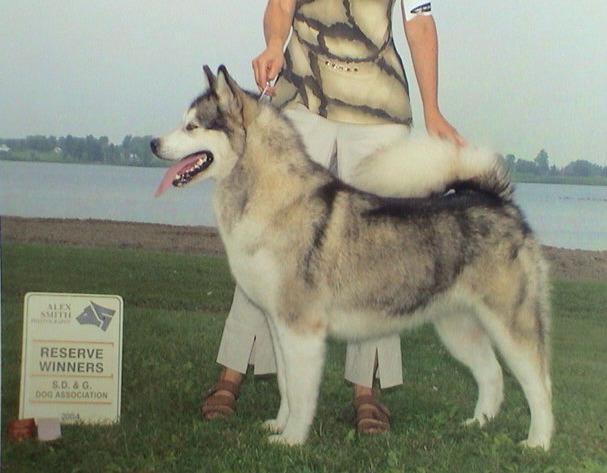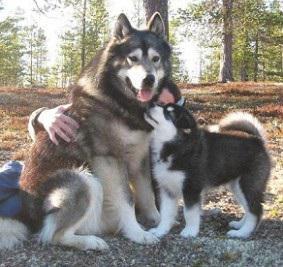The first image is the image on the left, the second image is the image on the right. Examine the images to the left and right. Is the description "The right image features one person standing behind a dog standing in profile, and the left image includes a person crouching behind a dog." accurate? Answer yes or no. No. The first image is the image on the left, the second image is the image on the right. Assess this claim about the two images: "The left and right image contains the same number of huskies.". Correct or not? Answer yes or no. No. 